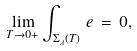<formula> <loc_0><loc_0><loc_500><loc_500>\lim _ { T \to 0 + } \int _ { \Sigma _ { \lambda } ( T ) } \, e \, = \, 0 ,</formula> 